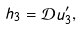Convert formula to latex. <formula><loc_0><loc_0><loc_500><loc_500>h _ { 3 } = { \mathcal { D } } u ^ { \prime } _ { 3 } ,</formula> 